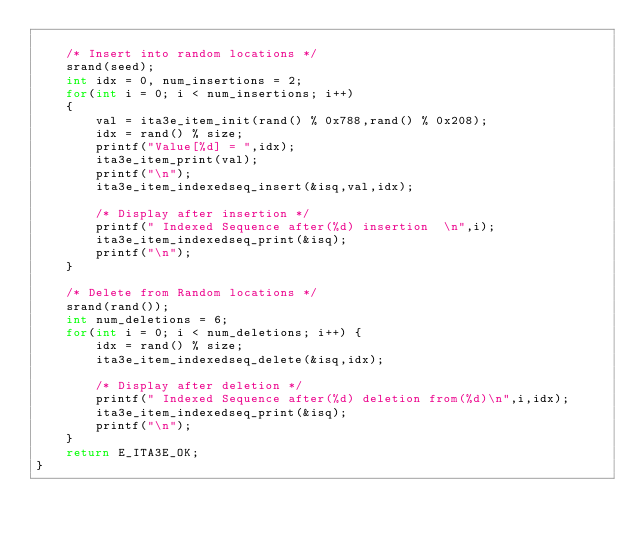Convert code to text. <code><loc_0><loc_0><loc_500><loc_500><_C_>	
	/* Insert into random locations */
	srand(seed);
	int idx = 0, num_insertions = 2;
	for(int i = 0; i < num_insertions; i++)
	{
		val = ita3e_item_init(rand() % 0x788,rand() % 0x208);
		idx = rand() % size;
		printf("Value[%d] = ",idx);
		ita3e_item_print(val);
		printf("\n");
		ita3e_item_indexedseq_insert(&isq,val,idx);

		/* Display after insertion */
		printf(" Indexed Sequence after(%d) insertion  \n",i);
		ita3e_item_indexedseq_print(&isq);
		printf("\n");
	}

	/* Delete from Random locations */
	srand(rand());
	int num_deletions = 6;
	for(int i = 0; i < num_deletions; i++) {
		idx = rand() % size;
		ita3e_item_indexedseq_delete(&isq,idx);
		
		/* Display after deletion */
		printf(" Indexed Sequence after(%d) deletion from(%d)\n",i,idx);
		ita3e_item_indexedseq_print(&isq);
		printf("\n");
	}
	return E_ITA3E_OK;
}
</code> 